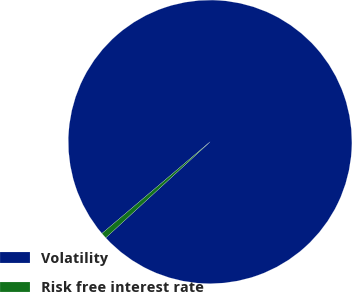<chart> <loc_0><loc_0><loc_500><loc_500><pie_chart><fcel>Volatility<fcel>Risk free interest rate<nl><fcel>99.35%<fcel>0.65%<nl></chart> 